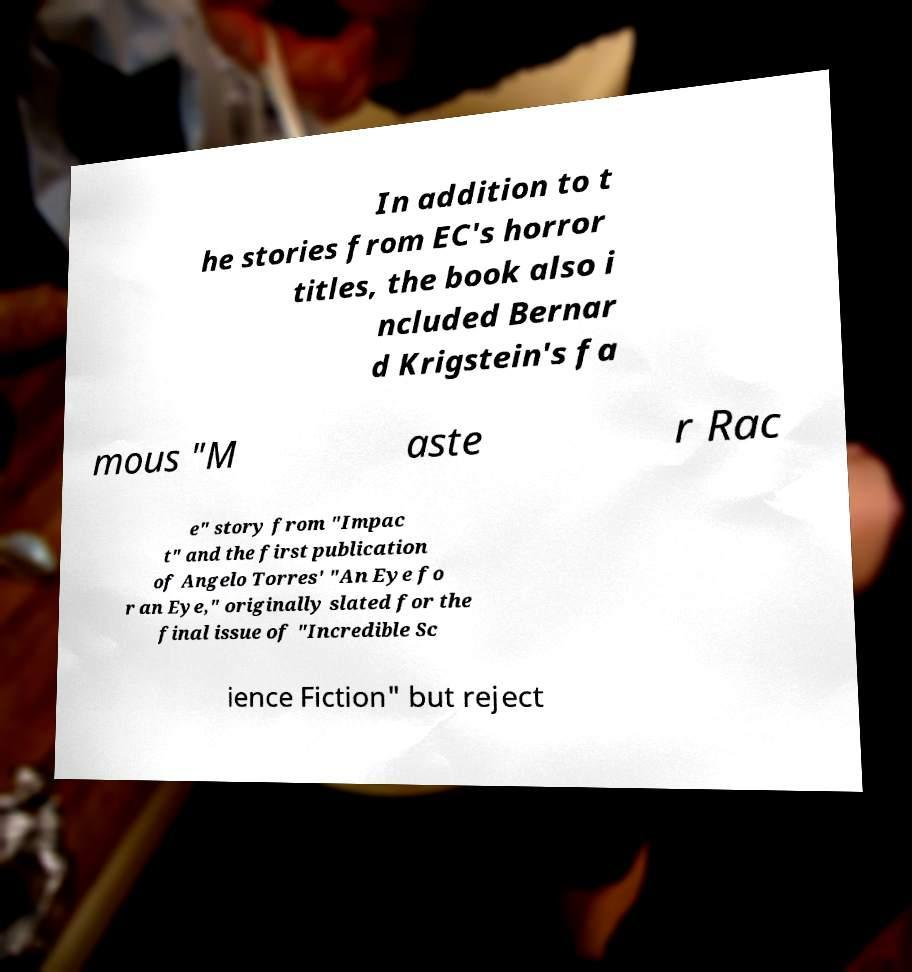Could you assist in decoding the text presented in this image and type it out clearly? In addition to t he stories from EC's horror titles, the book also i ncluded Bernar d Krigstein's fa mous "M aste r Rac e" story from "Impac t" and the first publication of Angelo Torres' "An Eye fo r an Eye," originally slated for the final issue of "Incredible Sc ience Fiction" but reject 